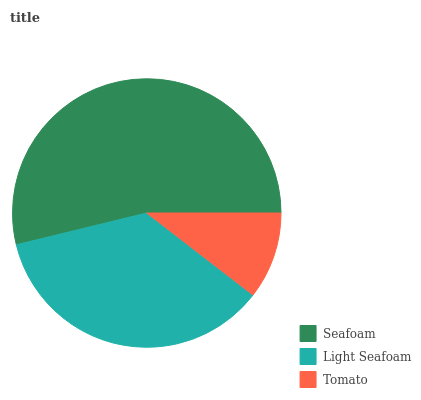Is Tomato the minimum?
Answer yes or no. Yes. Is Seafoam the maximum?
Answer yes or no. Yes. Is Light Seafoam the minimum?
Answer yes or no. No. Is Light Seafoam the maximum?
Answer yes or no. No. Is Seafoam greater than Light Seafoam?
Answer yes or no. Yes. Is Light Seafoam less than Seafoam?
Answer yes or no. Yes. Is Light Seafoam greater than Seafoam?
Answer yes or no. No. Is Seafoam less than Light Seafoam?
Answer yes or no. No. Is Light Seafoam the high median?
Answer yes or no. Yes. Is Light Seafoam the low median?
Answer yes or no. Yes. Is Seafoam the high median?
Answer yes or no. No. Is Seafoam the low median?
Answer yes or no. No. 